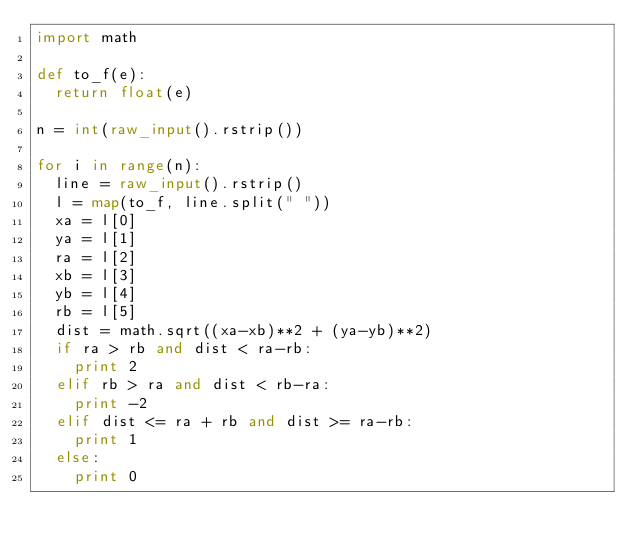<code> <loc_0><loc_0><loc_500><loc_500><_Python_>import math

def to_f(e):
  return float(e)

n = int(raw_input().rstrip())

for i in range(n):
  line = raw_input().rstrip()
  l = map(to_f, line.split(" "))
  xa = l[0]
  ya = l[1]
  ra = l[2]
  xb = l[3]
  yb = l[4]
  rb = l[5]
  dist = math.sqrt((xa-xb)**2 + (ya-yb)**2)
  if ra > rb and dist < ra-rb:
    print 2
  elif rb > ra and dist < rb-ra:
    print -2
  elif dist <= ra + rb and dist >= ra-rb:
    print 1
  else:
    print 0</code> 